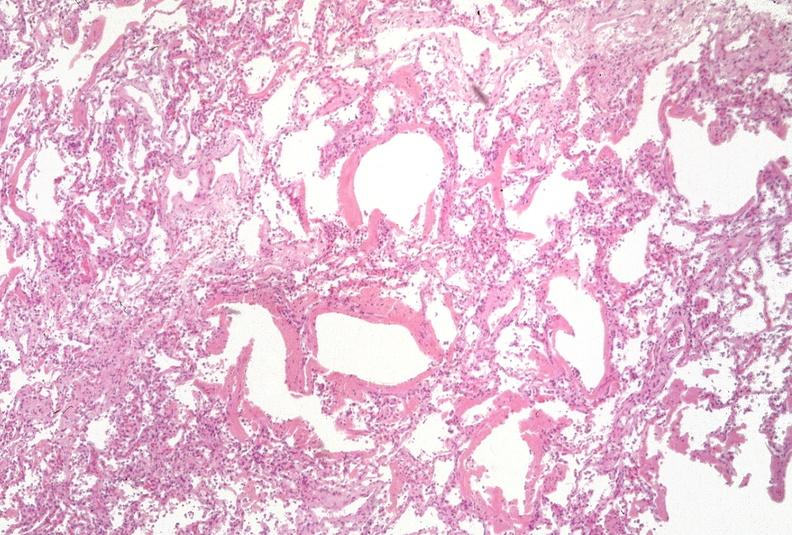s respiratory present?
Answer the question using a single word or phrase. Yes 